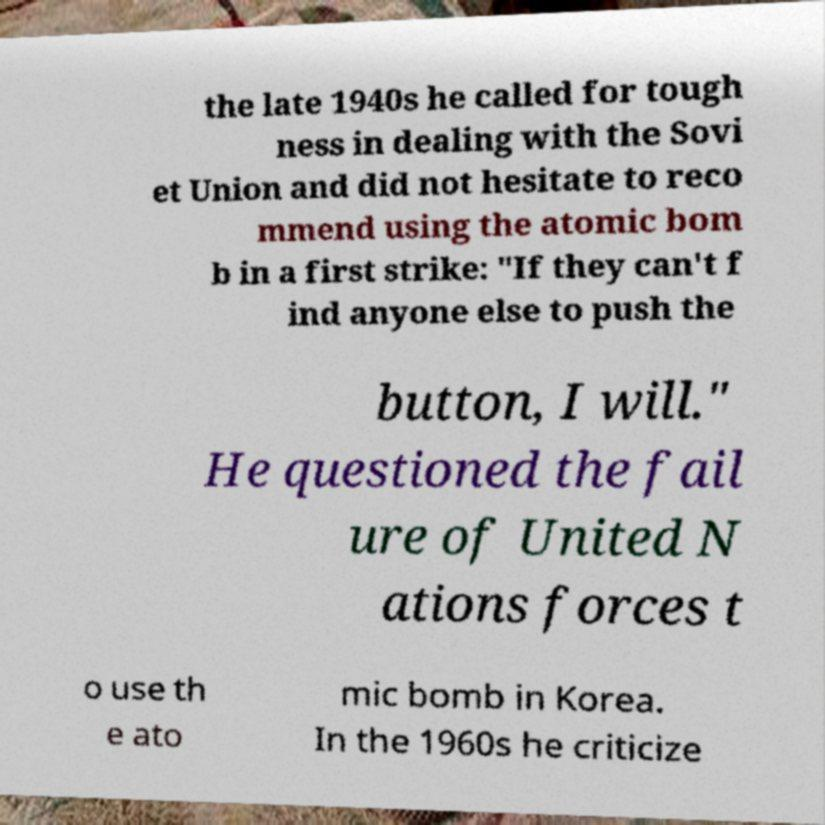There's text embedded in this image that I need extracted. Can you transcribe it verbatim? the late 1940s he called for tough ness in dealing with the Sovi et Union and did not hesitate to reco mmend using the atomic bom b in a first strike: "If they can't f ind anyone else to push the button, I will." He questioned the fail ure of United N ations forces t o use th e ato mic bomb in Korea. In the 1960s he criticize 